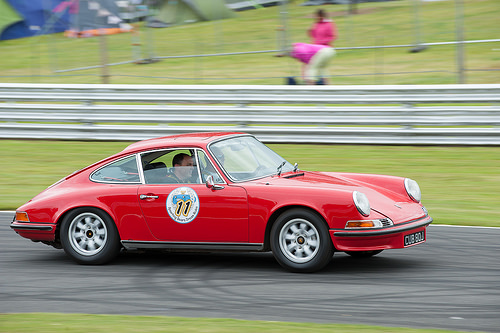<image>
Is there a woman next to the car? Yes. The woman is positioned adjacent to the car, located nearby in the same general area. Is there a person in the car? No. The person is not contained within the car. These objects have a different spatial relationship. Is the car on the rood? Yes. Looking at the image, I can see the car is positioned on top of the rood, with the rood providing support. 